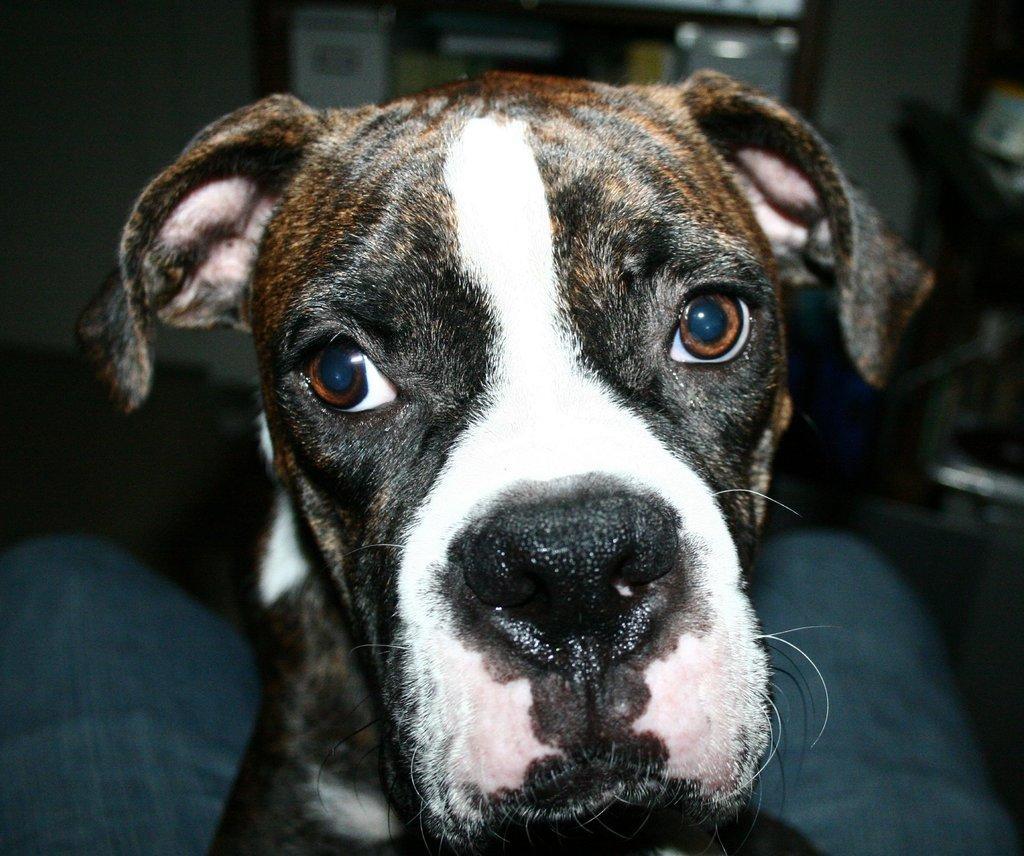Describe this image in one or two sentences. There is a black and white dog. In the background it is blurred. 